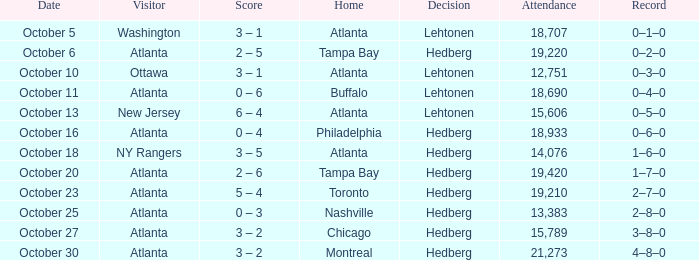What was the score for the game played on october 27? 3–8–0. 